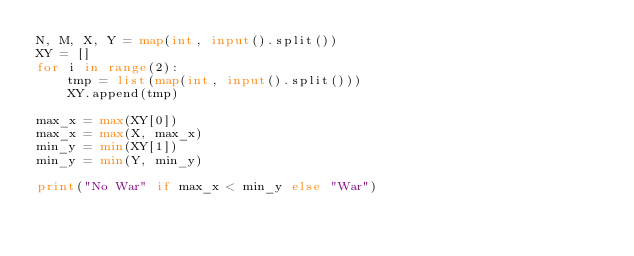Convert code to text. <code><loc_0><loc_0><loc_500><loc_500><_Python_>N, M, X, Y = map(int, input().split())
XY = []
for i in range(2):
    tmp = list(map(int, input().split()))
    XY.append(tmp)

max_x = max(XY[0])
max_x = max(X, max_x)
min_y = min(XY[1])
min_y = min(Y, min_y)

print("No War" if max_x < min_y else "War")
</code> 